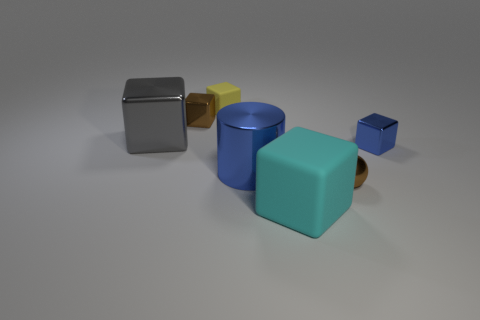Subtract 4 blocks. How many blocks are left? 1 Add 2 large cyan metallic things. How many objects exist? 9 Subtract all matte cubes. How many cubes are left? 3 Subtract all cubes. How many objects are left? 2 Subtract all yellow blocks. Subtract all gray balls. How many blocks are left? 4 Subtract all gray blocks. How many gray cylinders are left? 0 Subtract all large brown shiny things. Subtract all big cyan rubber things. How many objects are left? 6 Add 7 small cubes. How many small cubes are left? 10 Add 6 tiny brown shiny cubes. How many tiny brown shiny cubes exist? 7 Subtract all blue blocks. How many blocks are left? 4 